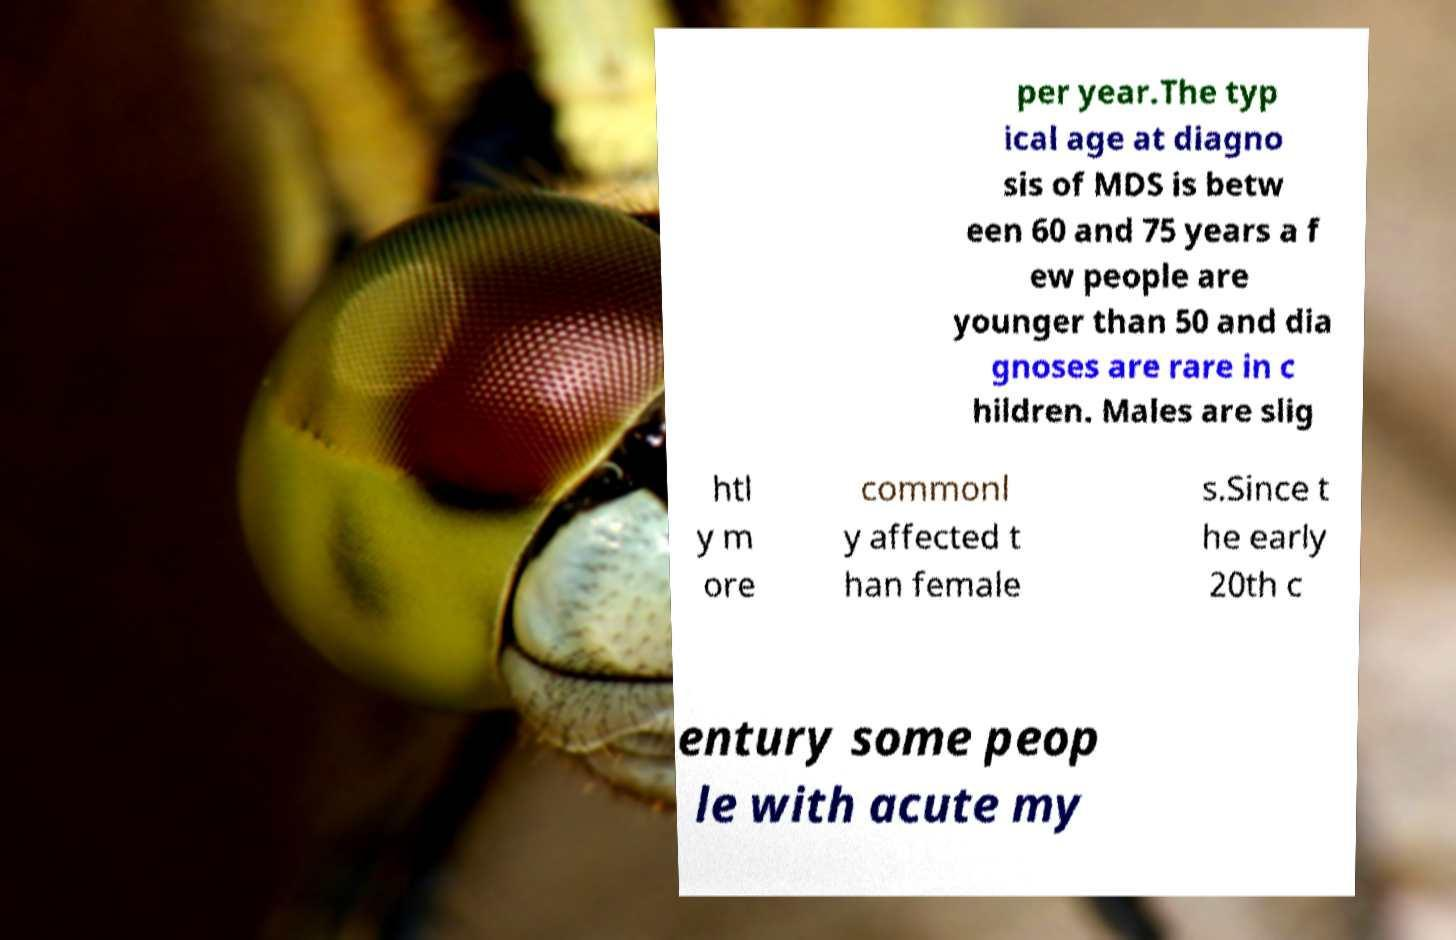Can you read and provide the text displayed in the image?This photo seems to have some interesting text. Can you extract and type it out for me? per year.The typ ical age at diagno sis of MDS is betw een 60 and 75 years a f ew people are younger than 50 and dia gnoses are rare in c hildren. Males are slig htl y m ore commonl y affected t han female s.Since t he early 20th c entury some peop le with acute my 